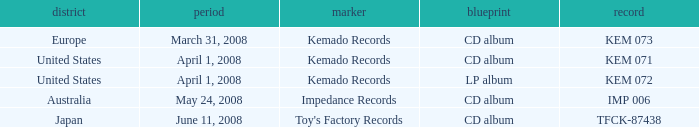Which Format has a Date of may 24, 2008? CD album. 